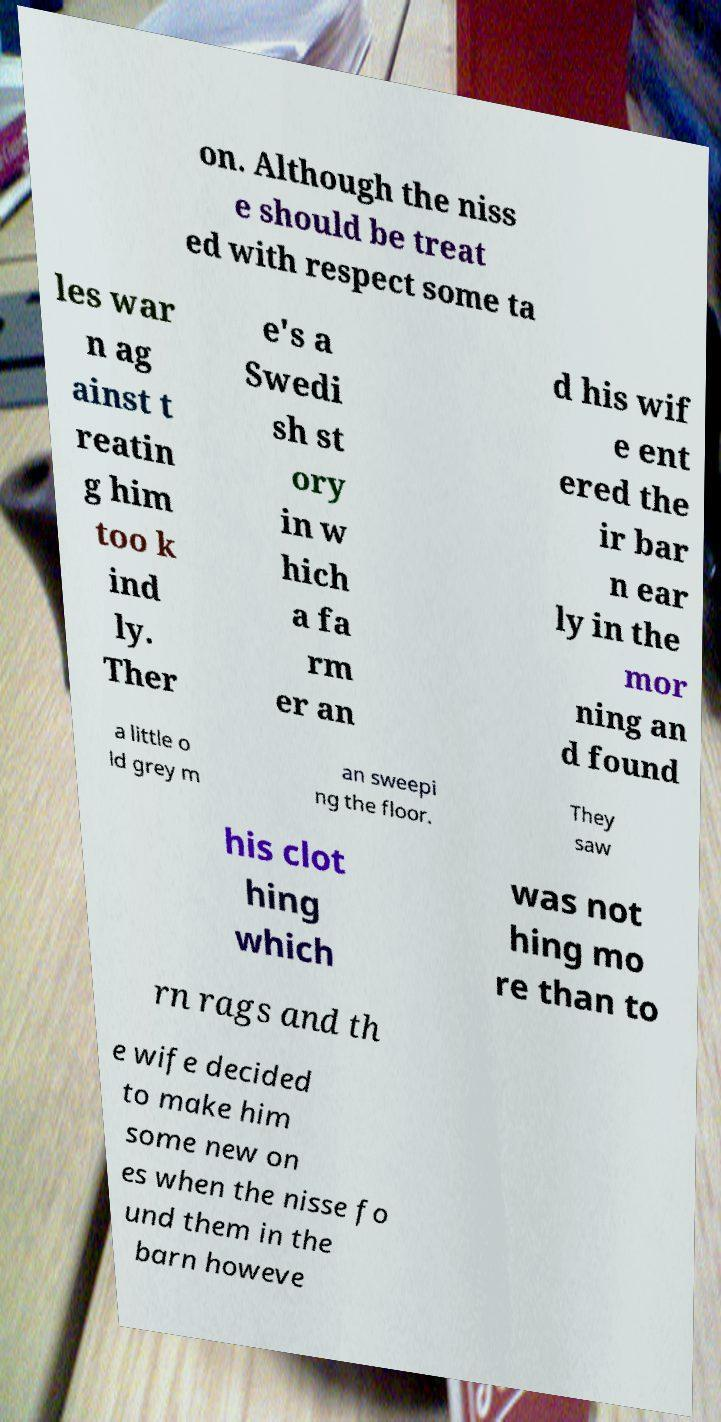There's text embedded in this image that I need extracted. Can you transcribe it verbatim? on. Although the niss e should be treat ed with respect some ta les war n ag ainst t reatin g him too k ind ly. Ther e's a Swedi sh st ory in w hich a fa rm er an d his wif e ent ered the ir bar n ear ly in the mor ning an d found a little o ld grey m an sweepi ng the floor. They saw his clot hing which was not hing mo re than to rn rags and th e wife decided to make him some new on es when the nisse fo und them in the barn howeve 